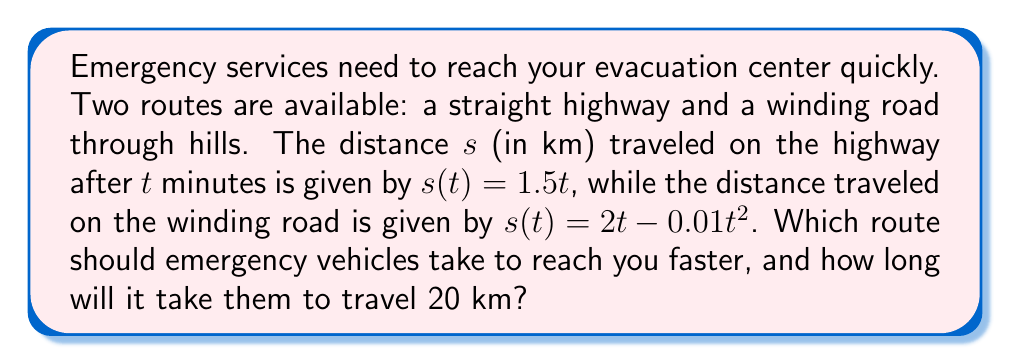What is the answer to this math problem? To solve this problem, we need to compare the time it takes for emergency vehicles to travel 20 km on each route.

1. Highway route:
   The velocity on the highway is constant and can be found by differentiating $s(t)$:
   $$v(t) = \frac{ds}{dt} = 1.5 \text{ km/min}$$
   Time to travel 20 km:
   $$t = \frac{s}{v} = \frac{20}{1.5} = 13.33 \text{ minutes}$$

2. Winding road:
   The velocity on the winding road is variable:
   $$v(t) = \frac{ds}{dt} = 2 - 0.02t \text{ km/min}$$
   To find the time, we need to solve:
   $$20 = 2t - 0.01t^2$$
   This quadratic equation can be solved:
   $$0.01t^2 - 2t + 20 = 0$$
   $$t = \frac{2 \pm \sqrt{4 - 4(0.01)(20)}}{2(0.01)} = \frac{2 \pm \sqrt{3.2}}{0.02}$$
   $$t = 11.40 \text{ or } 88.60 \text{ minutes}$$
   We choose the smaller value, 11.40 minutes.

3. Comparing the times:
   Highway: 13.33 minutes
   Winding road: 11.40 minutes

The winding road is faster, taking 11.40 minutes to travel 20 km.
Answer: Winding road; 11.40 minutes 